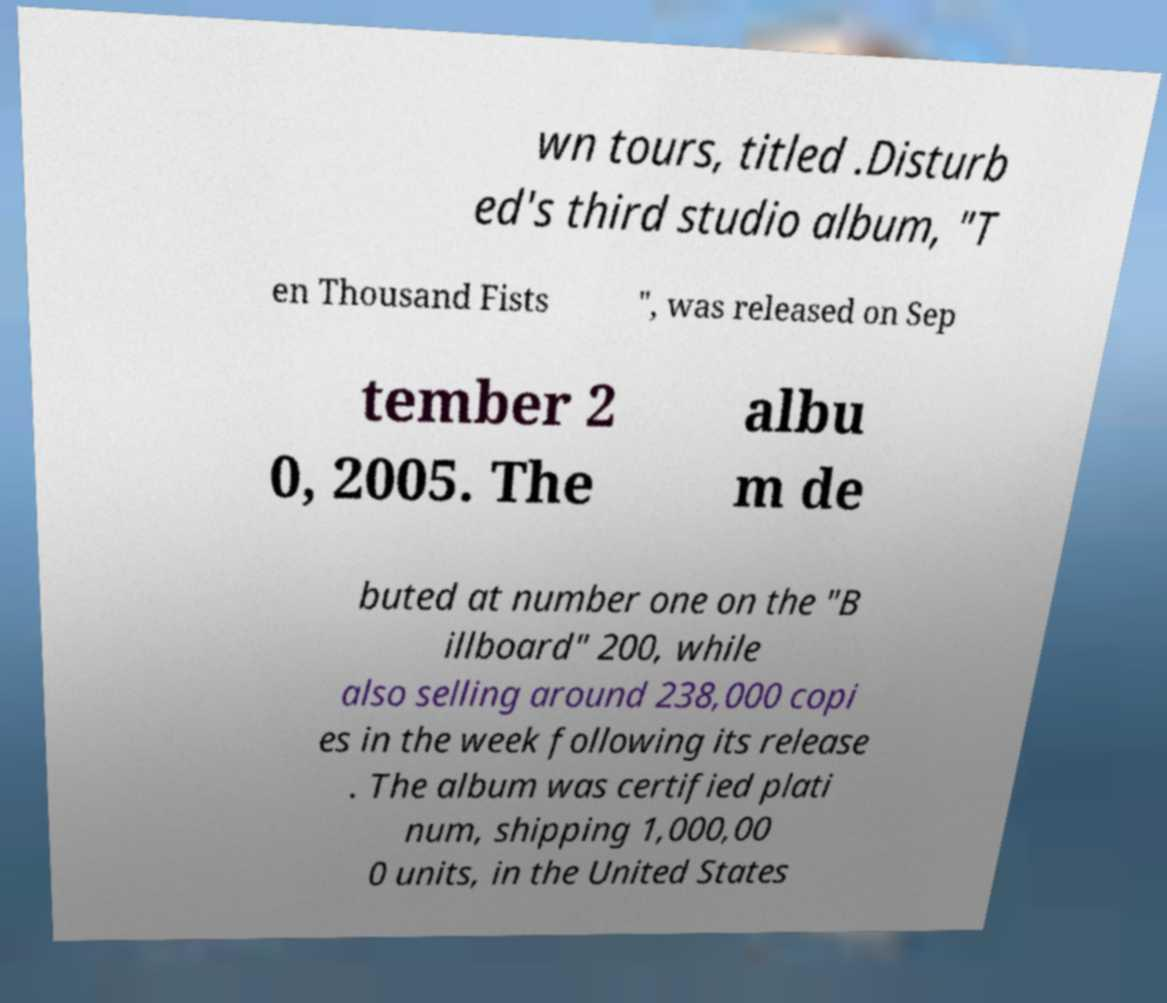Can you accurately transcribe the text from the provided image for me? wn tours, titled .Disturb ed's third studio album, "T en Thousand Fists ", was released on Sep tember 2 0, 2005. The albu m de buted at number one on the "B illboard" 200, while also selling around 238,000 copi es in the week following its release . The album was certified plati num, shipping 1,000,00 0 units, in the United States 